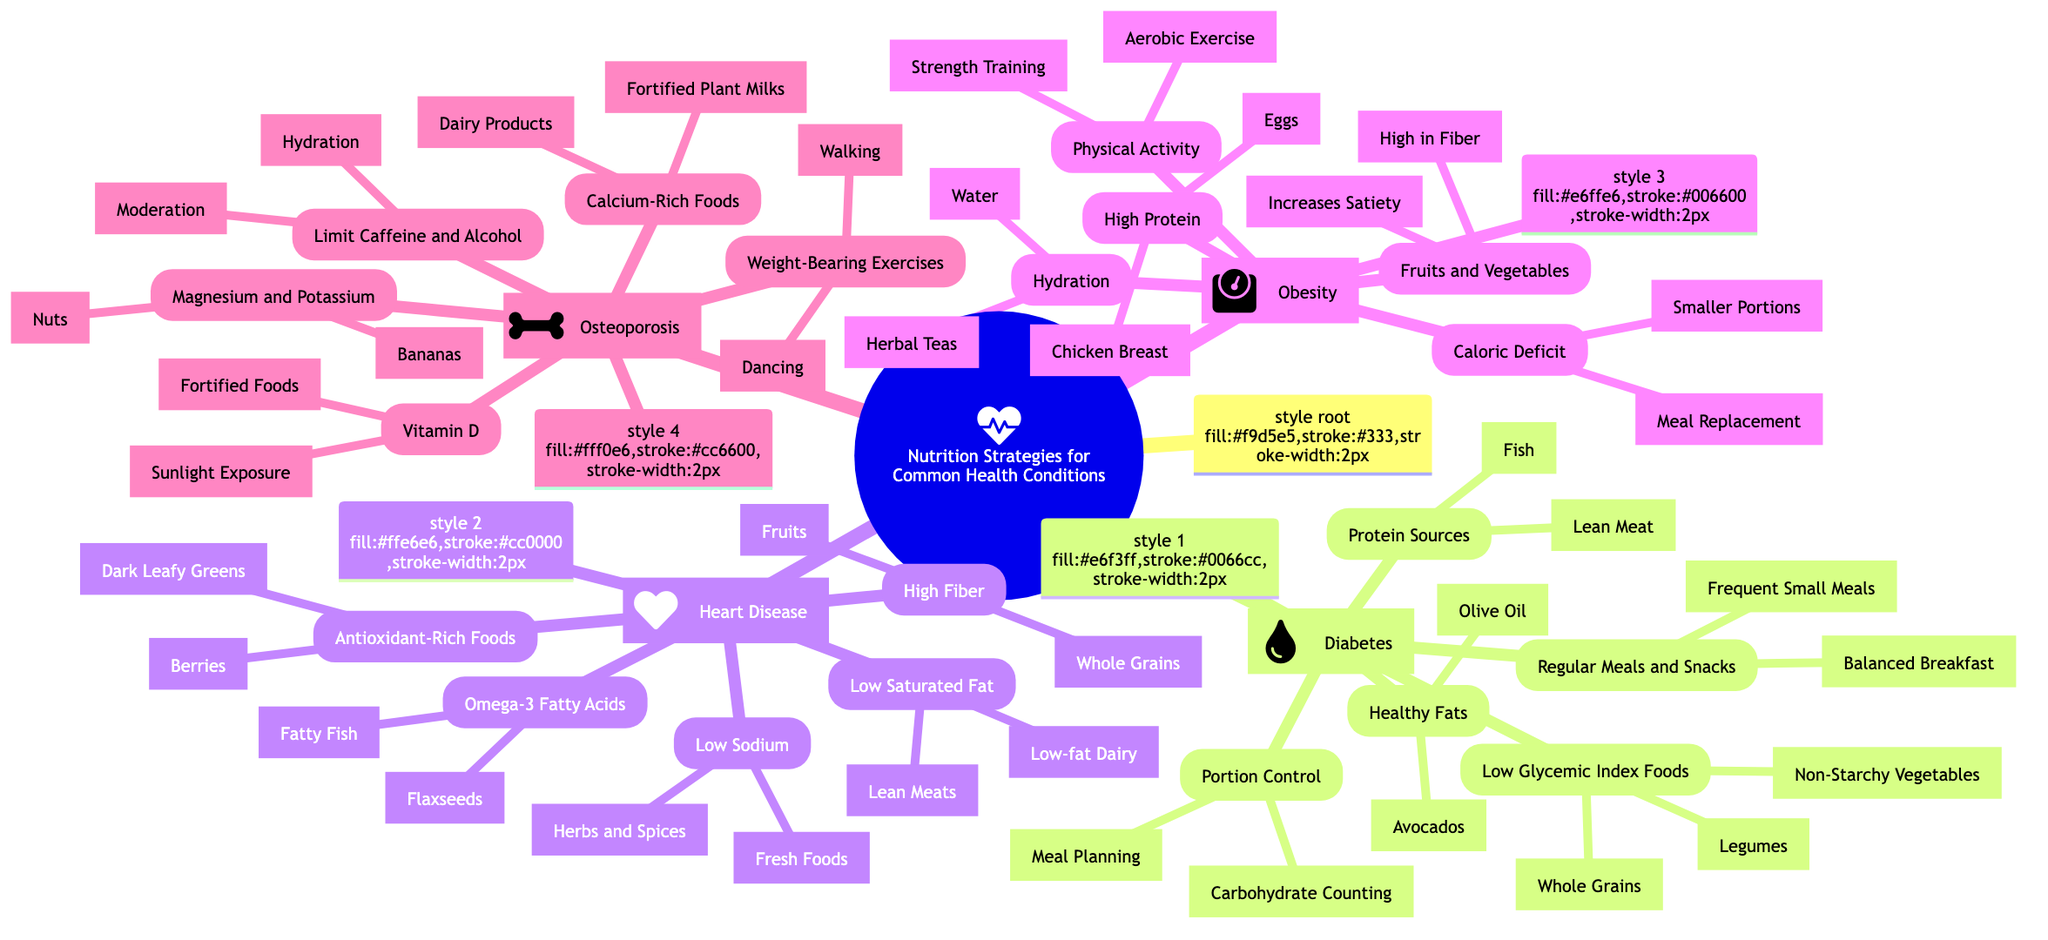What are three food categories related to diabetes? The diabetes section lists Low Glycemic Index Foods, Portion Control, and Regular Meals and Snacks. Within Low Glycemic Index Foods, three specific food categories are provided: Whole Grains, Legumes, and Non-Starchy Vegetables.
Answer: Whole Grains, Legumes, Non-Starchy Vegetables How many strategies are mentioned for heart disease? The heart disease section contains five nutrition strategies listed: Low Saturated Fat, High Fiber, Omega-3 Fatty Acids, Low Sodium, and Antioxidant-Rich Foods. Therefore, the answer is the total count of these strategies.
Answer: 5 Which protein source is mentioned for diabetes? Under the Protein Sources section in diabetes, specific examples are listed including Lean Meat, Fish, and Plant-based Proteins. Any one of these can be a valid answer but, for this question, we are focusing on the first item listed.
Answer: Lean Meat What is the relationship between obesity and physical activity? In the obesity section, Physical Activity is one of the strategies that prominently aligns with the goal of managing weight. Physical activity includes Aerobic Exercise, Strength Training, and Lifestyle Activity, all crucial for creating a caloric deficit. Therefore, the relationship is that physical activity is essential for weight management in obesity.
Answer: Essential for weight management Identify one dietary requirement for osteoporosis. The osteoporosis section highlights multiple dietary strategies including Calcium-Rich Foods and Vitamin D as key components for managing this condition. Focusing on Calcium-Rich Foods, the specific examples provided include Dairy Products, Fortified Plant Milks, and Leafy Greens, but just one example is needed.
Answer: Dairy Products 